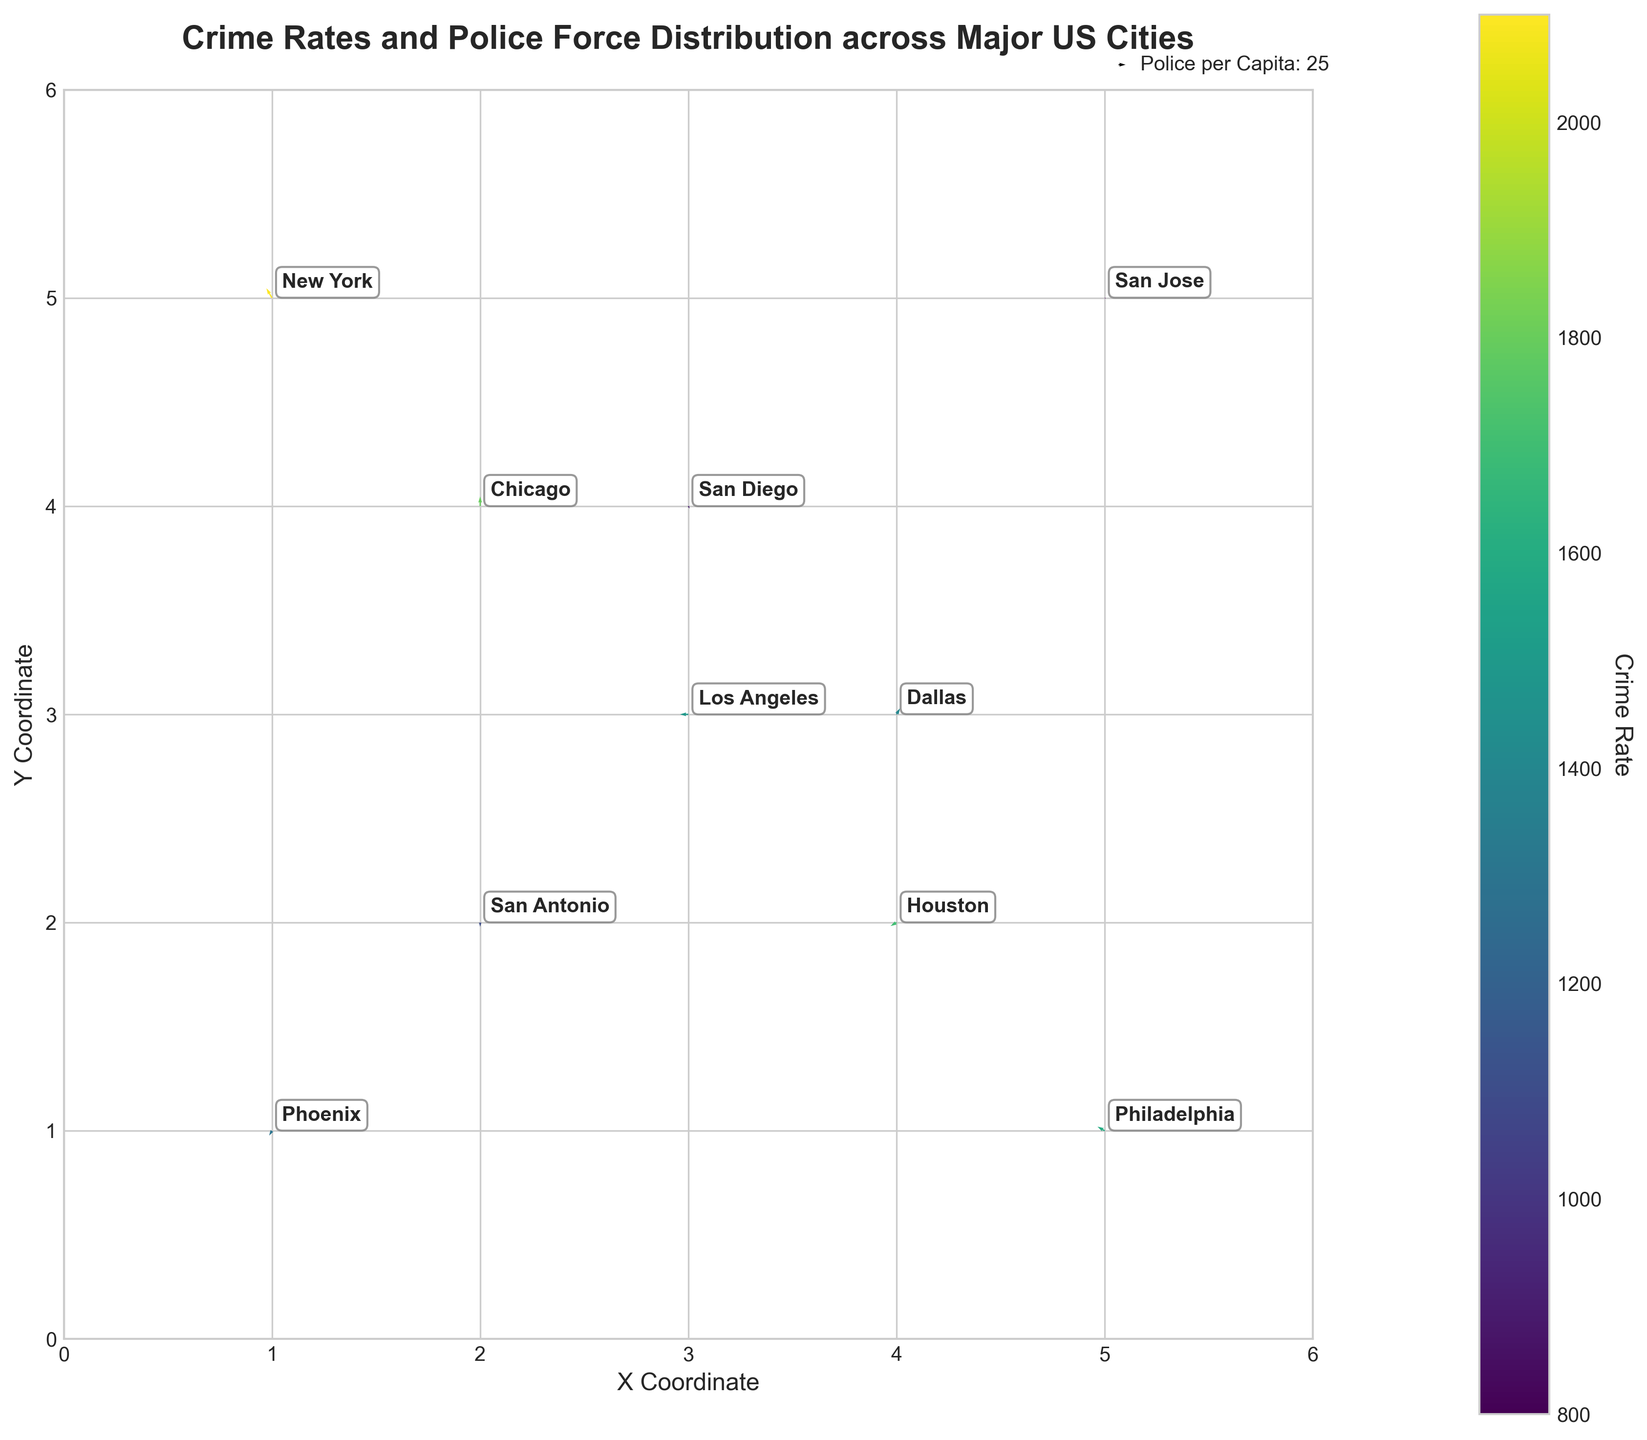What does the color of the arrows represent? The color of the arrows represents the crime rates in each city. This mapping is indicated by the colorbar on the right side of the plot, which shows a gradient from lower to higher crime rates.
Answer: Crime rates Which city has the highest crime rate according to the plot? By observing the color intensity on the arrows, New York has the highest crime rate, indicated by the darkest color on the colorbar.
Answer: New York What is the overall distribution of police per capita among the cities? The magnitude (length) of the arrows indicates police per capita. Longer arrows signify higher police per capita. Chicago and New York, with longer arrows, have higher values, while San Jose and San Diego, with shorter arrows, have lower values.
Answer: Varies, highest for Chicago and New York Which cities have the same X and Y coordinates? From the plot, the city coordinates can be checked. Phoenix (1, 1) and San Antonio (2, 2) are the cities with identical X and Y coordinates respectively.
Answer: Phoenix and San Antonio Which city has a lower crime rate, Dallas or Philadelphia? By comparing the colors of the arrows for Dallas and Philadelphia, we notice that Dallas has a lighter color arrow than Philadelphia, indicating a lower crime rate.
Answer: Dallas What direction does the arrow point for Houston, and what does it signify? The direction of the arrow for Houston is 210 degrees. This direction on the quiver plot box signifies the directionality of police force distribution, pointing southwest.
Answer: 210 degrees, southwest What is the range of the Y coordinates used in the plot? By observing the plot's Y-axis scale, the Y coordinates range from 0 to 6.
Answer: 0 to 6 Between Los Angeles and San Diego, which city has a higher police per capita? By comparing the lengths of the arrows, Los Angeles has a longer arrow than San Diego, which indicates a higher police per capita.
Answer: Los Angeles Calculate the average crime rate among New York, Chicago, and Los Angeles. New York has a crime rate of 2100, Chicago 1800, and Los Angeles 1500. Summing these gives a total of 5400, and dividing by 3 gives an average crime rate of 1800.
Answer: 1800 